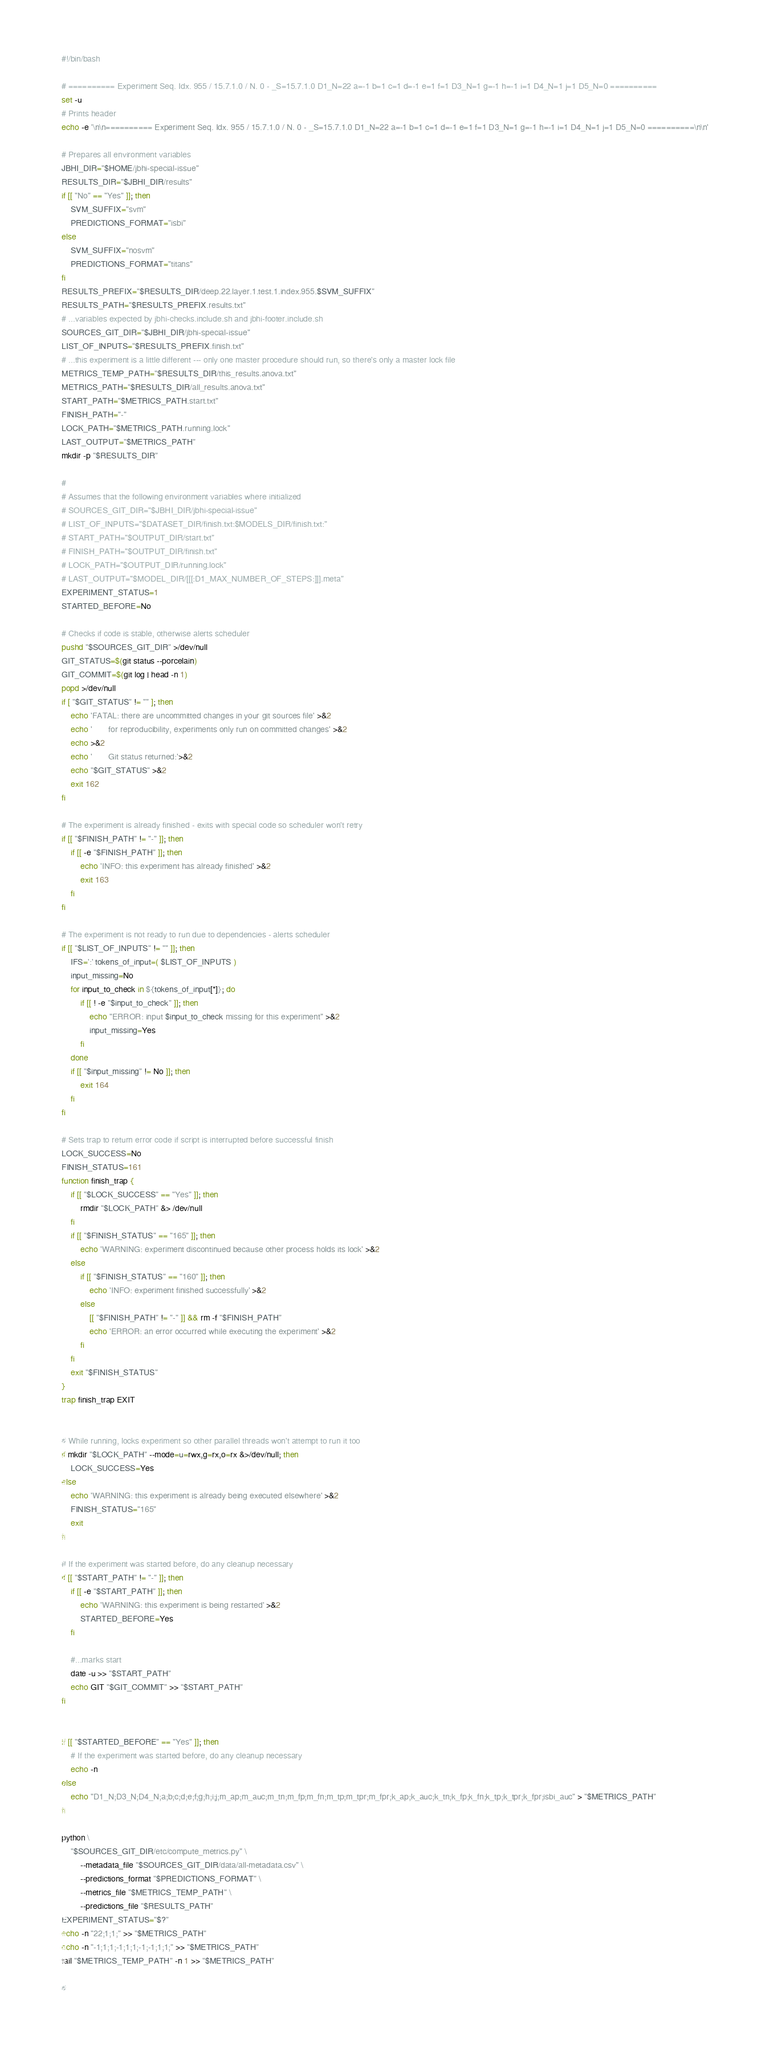Convert code to text. <code><loc_0><loc_0><loc_500><loc_500><_Bash_>#!/bin/bash

# ========== Experiment Seq. Idx. 955 / 15.7.1.0 / N. 0 - _S=15.7.1.0 D1_N=22 a=-1 b=1 c=1 d=-1 e=1 f=1 D3_N=1 g=-1 h=-1 i=1 D4_N=1 j=1 D5_N=0 ==========
set -u
# Prints header
echo -e '\n\n========== Experiment Seq. Idx. 955 / 15.7.1.0 / N. 0 - _S=15.7.1.0 D1_N=22 a=-1 b=1 c=1 d=-1 e=1 f=1 D3_N=1 g=-1 h=-1 i=1 D4_N=1 j=1 D5_N=0 ==========\n\n'

# Prepares all environment variables
JBHI_DIR="$HOME/jbhi-special-issue"
RESULTS_DIR="$JBHI_DIR/results"
if [[ "No" == "Yes" ]]; then
    SVM_SUFFIX="svm"
    PREDICTIONS_FORMAT="isbi"
else
    SVM_SUFFIX="nosvm"
    PREDICTIONS_FORMAT="titans"
fi
RESULTS_PREFIX="$RESULTS_DIR/deep.22.layer.1.test.1.index.955.$SVM_SUFFIX"
RESULTS_PATH="$RESULTS_PREFIX.results.txt"
# ...variables expected by jbhi-checks.include.sh and jbhi-footer.include.sh
SOURCES_GIT_DIR="$JBHI_DIR/jbhi-special-issue"
LIST_OF_INPUTS="$RESULTS_PREFIX.finish.txt"
# ...this experiment is a little different --- only one master procedure should run, so there's only a master lock file
METRICS_TEMP_PATH="$RESULTS_DIR/this_results.anova.txt"
METRICS_PATH="$RESULTS_DIR/all_results.anova.txt"
START_PATH="$METRICS_PATH.start.txt"
FINISH_PATH="-"
LOCK_PATH="$METRICS_PATH.running.lock"
LAST_OUTPUT="$METRICS_PATH"
mkdir -p "$RESULTS_DIR"

#
# Assumes that the following environment variables where initialized
# SOURCES_GIT_DIR="$JBHI_DIR/jbhi-special-issue"
# LIST_OF_INPUTS="$DATASET_DIR/finish.txt:$MODELS_DIR/finish.txt:"
# START_PATH="$OUTPUT_DIR/start.txt"
# FINISH_PATH="$OUTPUT_DIR/finish.txt"
# LOCK_PATH="$OUTPUT_DIR/running.lock"
# LAST_OUTPUT="$MODEL_DIR/[[[:D1_MAX_NUMBER_OF_STEPS:]]].meta"
EXPERIMENT_STATUS=1
STARTED_BEFORE=No

# Checks if code is stable, otherwise alerts scheduler
pushd "$SOURCES_GIT_DIR" >/dev/null
GIT_STATUS=$(git status --porcelain)
GIT_COMMIT=$(git log | head -n 1)
popd >/dev/null
if [ "$GIT_STATUS" != "" ]; then
    echo 'FATAL: there are uncommitted changes in your git sources file' >&2
    echo '       for reproducibility, experiments only run on committed changes' >&2
    echo >&2
    echo '       Git status returned:'>&2
    echo "$GIT_STATUS" >&2
    exit 162
fi

# The experiment is already finished - exits with special code so scheduler won't retry
if [[ "$FINISH_PATH" != "-" ]]; then
    if [[ -e "$FINISH_PATH" ]]; then
        echo 'INFO: this experiment has already finished' >&2
        exit 163
    fi
fi

# The experiment is not ready to run due to dependencies - alerts scheduler
if [[ "$LIST_OF_INPUTS" != "" ]]; then
    IFS=':' tokens_of_input=( $LIST_OF_INPUTS )
    input_missing=No
    for input_to_check in ${tokens_of_input[*]}; do
        if [[ ! -e "$input_to_check" ]]; then
            echo "ERROR: input $input_to_check missing for this experiment" >&2
            input_missing=Yes
        fi
    done
    if [[ "$input_missing" != No ]]; then
        exit 164
    fi
fi

# Sets trap to return error code if script is interrupted before successful finish
LOCK_SUCCESS=No
FINISH_STATUS=161
function finish_trap {
    if [[ "$LOCK_SUCCESS" == "Yes" ]]; then
        rmdir "$LOCK_PATH" &> /dev/null
    fi
    if [[ "$FINISH_STATUS" == "165" ]]; then
        echo 'WARNING: experiment discontinued because other process holds its lock' >&2
    else
        if [[ "$FINISH_STATUS" == "160" ]]; then
            echo 'INFO: experiment finished successfully' >&2
        else
            [[ "$FINISH_PATH" != "-" ]] && rm -f "$FINISH_PATH"
            echo 'ERROR: an error occurred while executing the experiment' >&2
        fi
    fi
    exit "$FINISH_STATUS"
}
trap finish_trap EXIT


# While running, locks experiment so other parallel threads won't attempt to run it too
if mkdir "$LOCK_PATH" --mode=u=rwx,g=rx,o=rx &>/dev/null; then
    LOCK_SUCCESS=Yes
else
    echo 'WARNING: this experiment is already being executed elsewhere' >&2
    FINISH_STATUS="165"
    exit
fi

# If the experiment was started before, do any cleanup necessary
if [[ "$START_PATH" != "-" ]]; then
    if [[ -e "$START_PATH" ]]; then
        echo 'WARNING: this experiment is being restarted' >&2
        STARTED_BEFORE=Yes
    fi

    #...marks start
    date -u >> "$START_PATH"
    echo GIT "$GIT_COMMIT" >> "$START_PATH"
fi


if [[ "$STARTED_BEFORE" == "Yes" ]]; then
    # If the experiment was started before, do any cleanup necessary
    echo -n
else
    echo "D1_N;D3_N;D4_N;a;b;c;d;e;f;g;h;i;j;m_ap;m_auc;m_tn;m_fp;m_fn;m_tp;m_tpr;m_fpr;k_ap;k_auc;k_tn;k_fp;k_fn;k_tp;k_tpr;k_fpr;isbi_auc" > "$METRICS_PATH"
fi

python \
    "$SOURCES_GIT_DIR/etc/compute_metrics.py" \
        --metadata_file "$SOURCES_GIT_DIR/data/all-metadata.csv" \
        --predictions_format "$PREDICTIONS_FORMAT" \
        --metrics_file "$METRICS_TEMP_PATH" \
        --predictions_file "$RESULTS_PATH"
EXPERIMENT_STATUS="$?"
echo -n "22;1;1;" >> "$METRICS_PATH"
echo -n "-1;1;1;-1;1;1;-1;-1;1;1;" >> "$METRICS_PATH"
tail "$METRICS_TEMP_PATH" -n 1 >> "$METRICS_PATH"

#</code> 